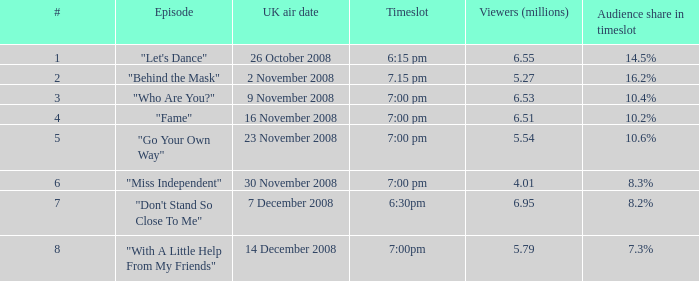Name the most number for viewers being 6.95 7.0. 